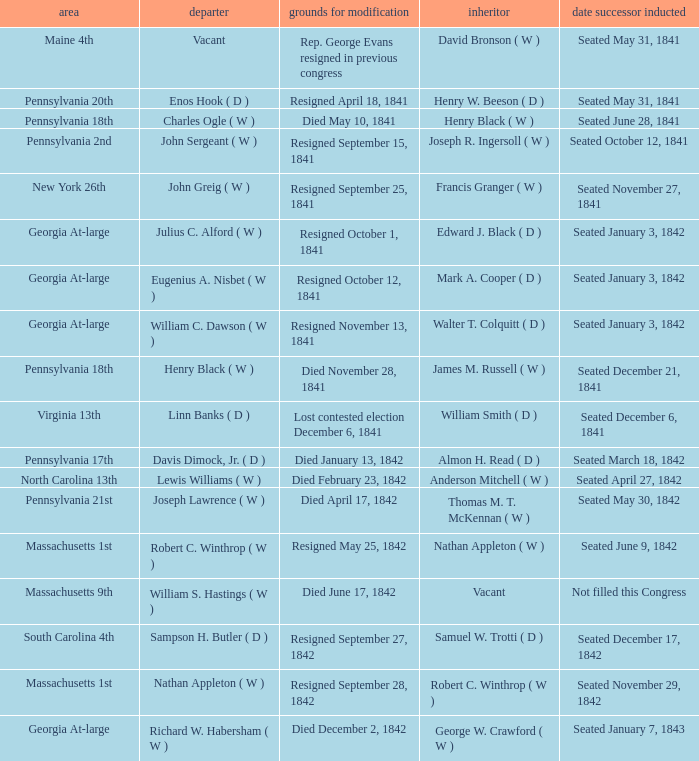When did the successor take office for pennsylvania's 17th congressional district? Seated March 18, 1842. 